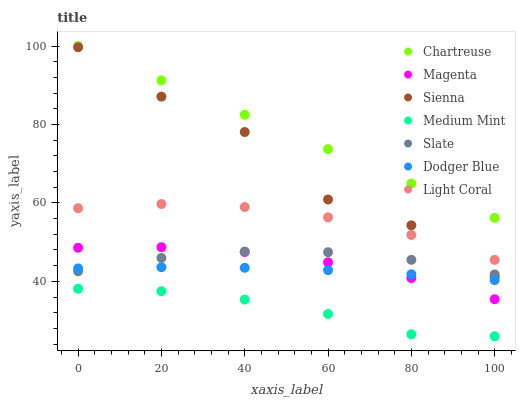Does Medium Mint have the minimum area under the curve?
Answer yes or no. Yes. Does Chartreuse have the maximum area under the curve?
Answer yes or no. Yes. Does Light Coral have the minimum area under the curve?
Answer yes or no. No. Does Light Coral have the maximum area under the curve?
Answer yes or no. No. Is Chartreuse the smoothest?
Answer yes or no. Yes. Is Sienna the roughest?
Answer yes or no. Yes. Is Light Coral the smoothest?
Answer yes or no. No. Is Light Coral the roughest?
Answer yes or no. No. Does Medium Mint have the lowest value?
Answer yes or no. Yes. Does Light Coral have the lowest value?
Answer yes or no. No. Does Chartreuse have the highest value?
Answer yes or no. Yes. Does Light Coral have the highest value?
Answer yes or no. No. Is Light Coral less than Chartreuse?
Answer yes or no. Yes. Is Chartreuse greater than Dodger Blue?
Answer yes or no. Yes. Does Magenta intersect Dodger Blue?
Answer yes or no. Yes. Is Magenta less than Dodger Blue?
Answer yes or no. No. Is Magenta greater than Dodger Blue?
Answer yes or no. No. Does Light Coral intersect Chartreuse?
Answer yes or no. No. 